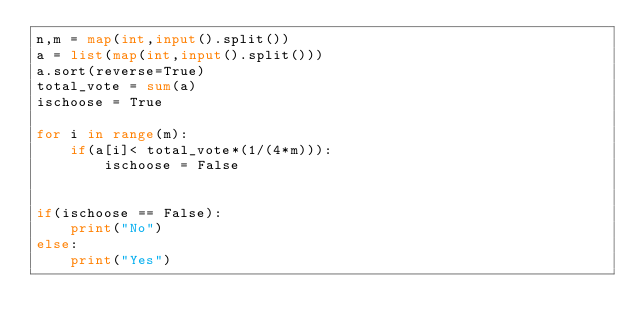<code> <loc_0><loc_0><loc_500><loc_500><_Python_>n,m = map(int,input().split())
a = list(map(int,input().split()))
a.sort(reverse=True)
total_vote = sum(a)
ischoose = True

for i in range(m):
    if(a[i]< total_vote*(1/(4*m))):
        ischoose = False
    

if(ischoose == False):
    print("No")
else:
    print("Yes")
</code> 